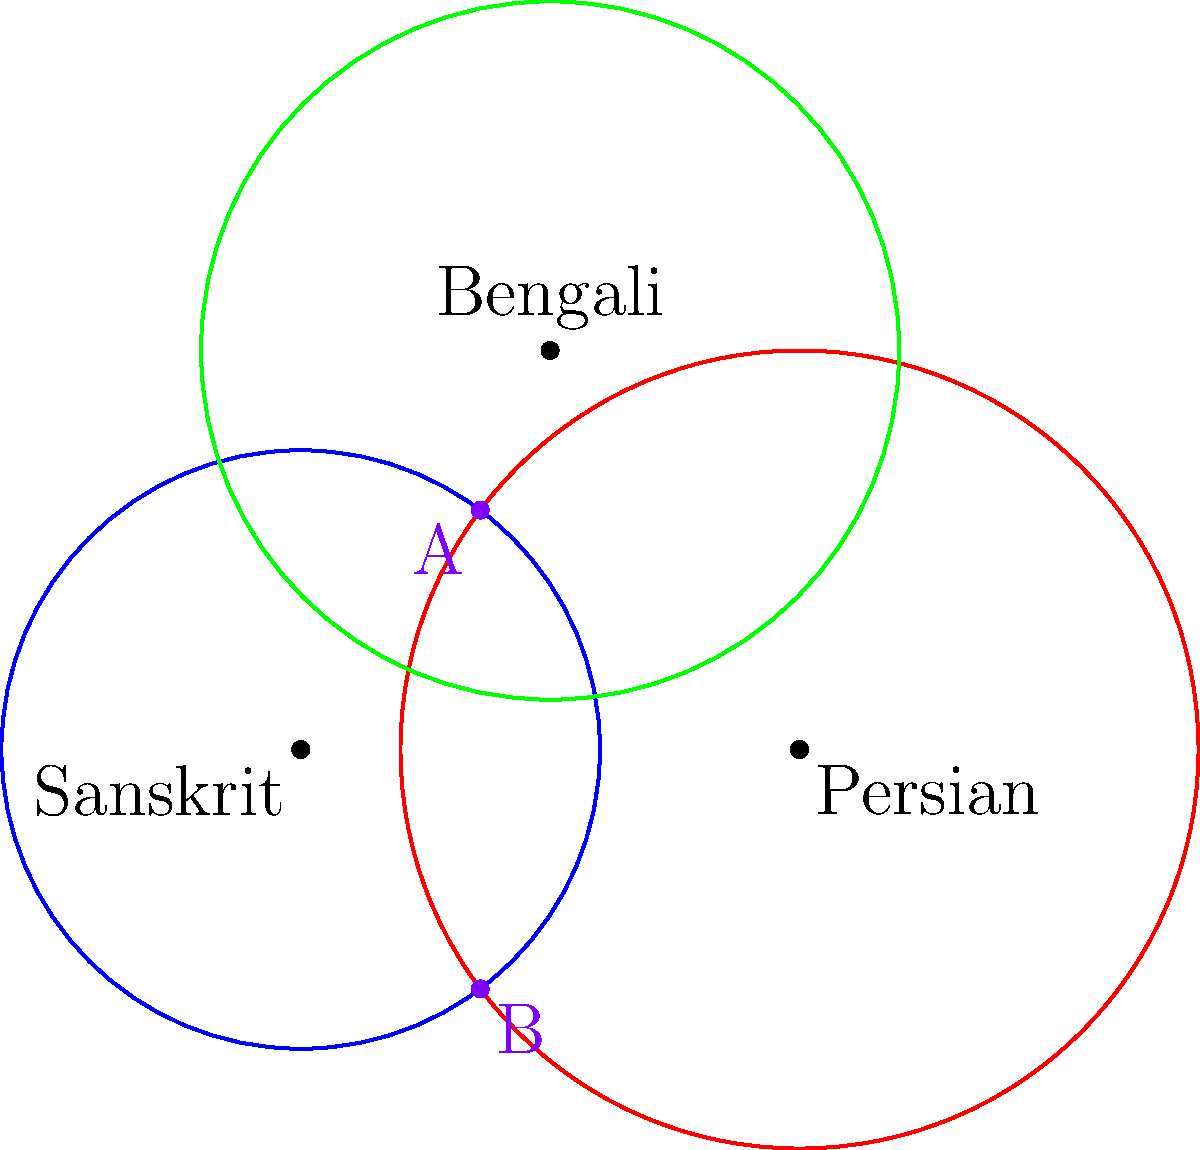In the context of language influence zones in South Asia, three circles represent the spread of Sanskrit (blue), Persian (red), and Bengali (green). The centers and radii of these circles are:

Sanskrit: center (0,0), radius 3 units
Persian: center (5,0), radius 4 units
Bengali: center (2.5,4), radius 3.5 units

Points A and B represent the intersection of Sanskrit and Persian influence zones. Calculate the y-coordinate of point A, which is closer to the origin. How might this intersection point reflect the historical interaction between Sanskrit and Persian in South Asia? To find the y-coordinate of point A, we need to solve the system of equations for the circles representing Sanskrit and Persian influence:

1) Sanskrit circle equation: $x^2 + y^2 = 3^2 = 9$
2) Persian circle equation: $(x-5)^2 + y^2 = 4^2 = 16$

Subtracting equation 1 from equation 2:
3) $(x-5)^2 - x^2 = 16 - 9$
4) $x^2 - 10x + 25 - x^2 = 7$
5) $-10x = -18$
6) $x = 1.8$

Substituting this x-value back into equation 1:
7) $(1.8)^2 + y^2 = 9$
8) $y^2 = 9 - 3.24 = 5.76$
9) $y = \pm \sqrt{5.76} = \pm 2.4$

The y-coordinate closer to the origin is the positive value: 2.4.

This intersection point reflects the historical interaction between Sanskrit and Persian in South Asia by representing a geographical area where both languages had significant influence. The y-coordinate of 2.4 suggests a substantial overlap between the two language zones, indicating a region where linguistic and cultural exchange between Sanskrit and Persian traditions was likely intense. This could correspond to areas in northern India where Persian influence was strong during periods of Islamic rule, yet Sanskrit maintained its cultural significance.
Answer: y-coordinate of A: 2.4 